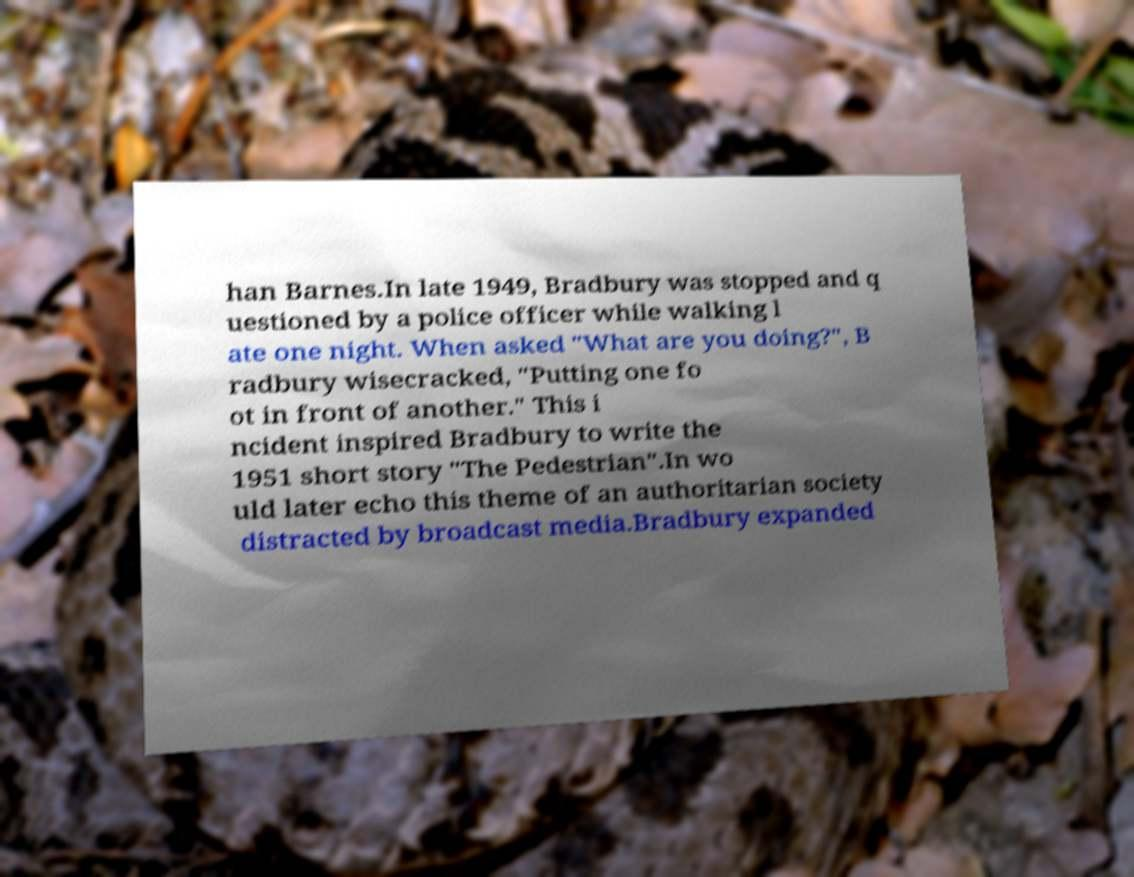I need the written content from this picture converted into text. Can you do that? han Barnes.In late 1949, Bradbury was stopped and q uestioned by a police officer while walking l ate one night. When asked "What are you doing?", B radbury wisecracked, "Putting one fo ot in front of another." This i ncident inspired Bradbury to write the 1951 short story "The Pedestrian".In wo uld later echo this theme of an authoritarian society distracted by broadcast media.Bradbury expanded 